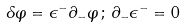Convert formula to latex. <formula><loc_0><loc_0><loc_500><loc_500>\delta \varphi = \epsilon ^ { - } \partial _ { - } \varphi \, ; \, \partial _ { - } \epsilon ^ { - } = 0</formula> 